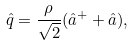Convert formula to latex. <formula><loc_0><loc_0><loc_500><loc_500>\hat { q } = \frac { \rho } { \sqrt { 2 } } ( \hat { a } ^ { + } + \hat { a } ) ,</formula> 